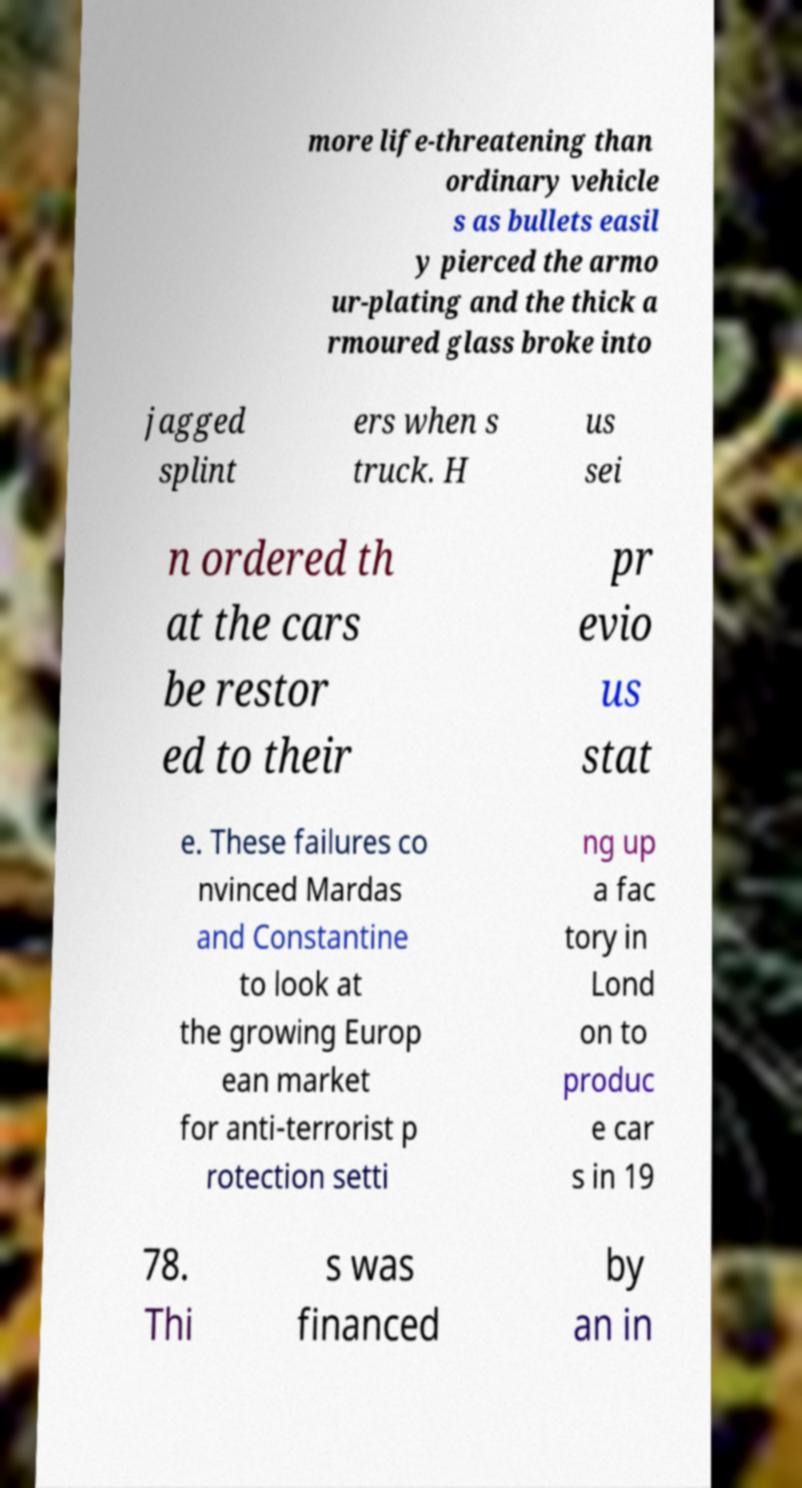Please read and relay the text visible in this image. What does it say? more life-threatening than ordinary vehicle s as bullets easil y pierced the armo ur-plating and the thick a rmoured glass broke into jagged splint ers when s truck. H us sei n ordered th at the cars be restor ed to their pr evio us stat e. These failures co nvinced Mardas and Constantine to look at the growing Europ ean market for anti-terrorist p rotection setti ng up a fac tory in Lond on to produc e car s in 19 78. Thi s was financed by an in 